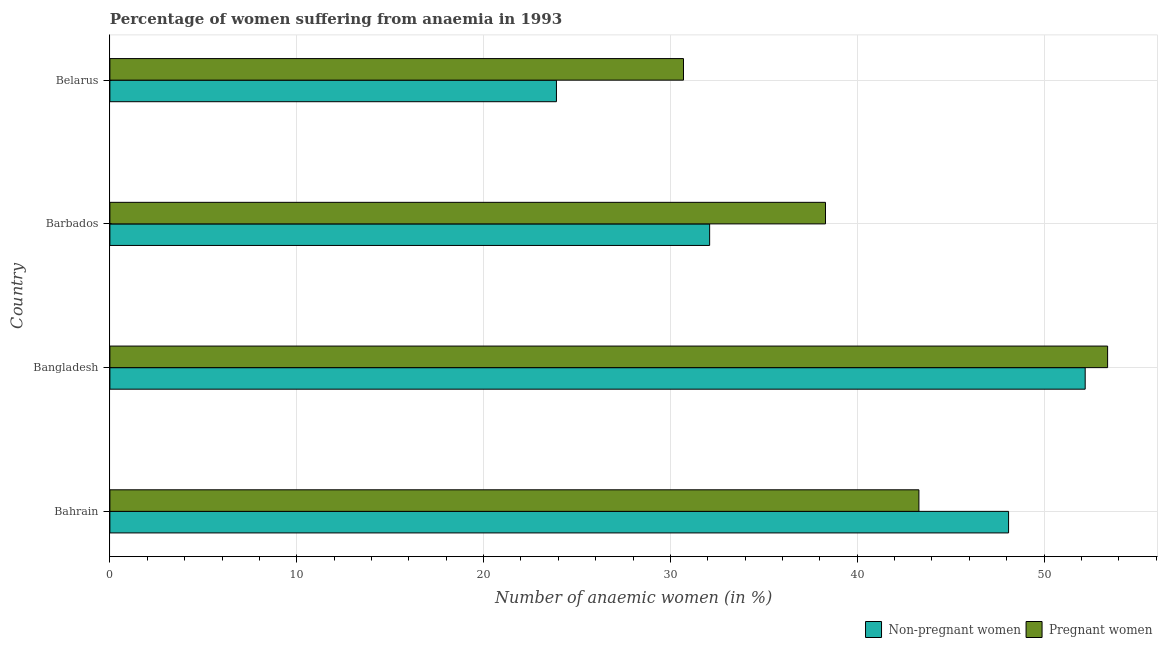Are the number of bars per tick equal to the number of legend labels?
Ensure brevity in your answer.  Yes. How many bars are there on the 1st tick from the bottom?
Offer a terse response. 2. What is the label of the 1st group of bars from the top?
Keep it short and to the point. Belarus. In how many cases, is the number of bars for a given country not equal to the number of legend labels?
Your response must be concise. 0. What is the percentage of pregnant anaemic women in Bangladesh?
Make the answer very short. 53.4. Across all countries, what is the maximum percentage of non-pregnant anaemic women?
Provide a succinct answer. 52.2. Across all countries, what is the minimum percentage of non-pregnant anaemic women?
Offer a terse response. 23.9. In which country was the percentage of pregnant anaemic women minimum?
Offer a terse response. Belarus. What is the total percentage of non-pregnant anaemic women in the graph?
Make the answer very short. 156.3. What is the difference between the percentage of non-pregnant anaemic women in Bangladesh and that in Barbados?
Ensure brevity in your answer.  20.1. What is the difference between the percentage of non-pregnant anaemic women in Bangladesh and the percentage of pregnant anaemic women in Belarus?
Ensure brevity in your answer.  21.5. What is the average percentage of pregnant anaemic women per country?
Offer a terse response. 41.42. In how many countries, is the percentage of non-pregnant anaemic women greater than 42 %?
Offer a terse response. 2. What is the ratio of the percentage of pregnant anaemic women in Bahrain to that in Barbados?
Your answer should be compact. 1.13. What is the difference between the highest and the lowest percentage of pregnant anaemic women?
Offer a very short reply. 22.7. Is the sum of the percentage of non-pregnant anaemic women in Bangladesh and Barbados greater than the maximum percentage of pregnant anaemic women across all countries?
Make the answer very short. Yes. What does the 1st bar from the top in Bangladesh represents?
Provide a succinct answer. Pregnant women. What does the 1st bar from the bottom in Bangladesh represents?
Provide a succinct answer. Non-pregnant women. How many bars are there?
Keep it short and to the point. 8. Are the values on the major ticks of X-axis written in scientific E-notation?
Your response must be concise. No. Does the graph contain any zero values?
Ensure brevity in your answer.  No. Does the graph contain grids?
Offer a terse response. Yes. Where does the legend appear in the graph?
Provide a short and direct response. Bottom right. How many legend labels are there?
Offer a very short reply. 2. What is the title of the graph?
Keep it short and to the point. Percentage of women suffering from anaemia in 1993. Does "Taxes on profits and capital gains" appear as one of the legend labels in the graph?
Provide a short and direct response. No. What is the label or title of the X-axis?
Provide a short and direct response. Number of anaemic women (in %). What is the Number of anaemic women (in %) in Non-pregnant women in Bahrain?
Offer a very short reply. 48.1. What is the Number of anaemic women (in %) in Pregnant women in Bahrain?
Your answer should be compact. 43.3. What is the Number of anaemic women (in %) of Non-pregnant women in Bangladesh?
Your answer should be very brief. 52.2. What is the Number of anaemic women (in %) in Pregnant women in Bangladesh?
Offer a terse response. 53.4. What is the Number of anaemic women (in %) in Non-pregnant women in Barbados?
Your answer should be compact. 32.1. What is the Number of anaemic women (in %) in Pregnant women in Barbados?
Offer a very short reply. 38.3. What is the Number of anaemic women (in %) in Non-pregnant women in Belarus?
Offer a terse response. 23.9. What is the Number of anaemic women (in %) of Pregnant women in Belarus?
Give a very brief answer. 30.7. Across all countries, what is the maximum Number of anaemic women (in %) in Non-pregnant women?
Offer a terse response. 52.2. Across all countries, what is the maximum Number of anaemic women (in %) of Pregnant women?
Make the answer very short. 53.4. Across all countries, what is the minimum Number of anaemic women (in %) in Non-pregnant women?
Give a very brief answer. 23.9. Across all countries, what is the minimum Number of anaemic women (in %) in Pregnant women?
Keep it short and to the point. 30.7. What is the total Number of anaemic women (in %) in Non-pregnant women in the graph?
Provide a succinct answer. 156.3. What is the total Number of anaemic women (in %) in Pregnant women in the graph?
Offer a terse response. 165.7. What is the difference between the Number of anaemic women (in %) of Pregnant women in Bahrain and that in Bangladesh?
Offer a terse response. -10.1. What is the difference between the Number of anaemic women (in %) of Non-pregnant women in Bahrain and that in Barbados?
Provide a succinct answer. 16. What is the difference between the Number of anaemic women (in %) in Non-pregnant women in Bahrain and that in Belarus?
Provide a succinct answer. 24.2. What is the difference between the Number of anaemic women (in %) in Pregnant women in Bahrain and that in Belarus?
Your response must be concise. 12.6. What is the difference between the Number of anaemic women (in %) in Non-pregnant women in Bangladesh and that in Barbados?
Offer a terse response. 20.1. What is the difference between the Number of anaemic women (in %) of Non-pregnant women in Bangladesh and that in Belarus?
Your answer should be very brief. 28.3. What is the difference between the Number of anaemic women (in %) in Pregnant women in Bangladesh and that in Belarus?
Make the answer very short. 22.7. What is the difference between the Number of anaemic women (in %) in Pregnant women in Barbados and that in Belarus?
Ensure brevity in your answer.  7.6. What is the difference between the Number of anaemic women (in %) of Non-pregnant women in Bahrain and the Number of anaemic women (in %) of Pregnant women in Barbados?
Keep it short and to the point. 9.8. What is the difference between the Number of anaemic women (in %) in Non-pregnant women in Bahrain and the Number of anaemic women (in %) in Pregnant women in Belarus?
Provide a succinct answer. 17.4. What is the difference between the Number of anaemic women (in %) of Non-pregnant women in Barbados and the Number of anaemic women (in %) of Pregnant women in Belarus?
Provide a short and direct response. 1.4. What is the average Number of anaemic women (in %) in Non-pregnant women per country?
Ensure brevity in your answer.  39.08. What is the average Number of anaemic women (in %) in Pregnant women per country?
Offer a terse response. 41.42. What is the difference between the Number of anaemic women (in %) of Non-pregnant women and Number of anaemic women (in %) of Pregnant women in Bahrain?
Give a very brief answer. 4.8. What is the difference between the Number of anaemic women (in %) in Non-pregnant women and Number of anaemic women (in %) in Pregnant women in Bangladesh?
Ensure brevity in your answer.  -1.2. What is the ratio of the Number of anaemic women (in %) of Non-pregnant women in Bahrain to that in Bangladesh?
Provide a short and direct response. 0.92. What is the ratio of the Number of anaemic women (in %) in Pregnant women in Bahrain to that in Bangladesh?
Provide a succinct answer. 0.81. What is the ratio of the Number of anaemic women (in %) in Non-pregnant women in Bahrain to that in Barbados?
Your answer should be compact. 1.5. What is the ratio of the Number of anaemic women (in %) of Pregnant women in Bahrain to that in Barbados?
Your response must be concise. 1.13. What is the ratio of the Number of anaemic women (in %) in Non-pregnant women in Bahrain to that in Belarus?
Ensure brevity in your answer.  2.01. What is the ratio of the Number of anaemic women (in %) in Pregnant women in Bahrain to that in Belarus?
Give a very brief answer. 1.41. What is the ratio of the Number of anaemic women (in %) in Non-pregnant women in Bangladesh to that in Barbados?
Ensure brevity in your answer.  1.63. What is the ratio of the Number of anaemic women (in %) of Pregnant women in Bangladesh to that in Barbados?
Provide a succinct answer. 1.39. What is the ratio of the Number of anaemic women (in %) in Non-pregnant women in Bangladesh to that in Belarus?
Provide a short and direct response. 2.18. What is the ratio of the Number of anaemic women (in %) in Pregnant women in Bangladesh to that in Belarus?
Provide a short and direct response. 1.74. What is the ratio of the Number of anaemic women (in %) in Non-pregnant women in Barbados to that in Belarus?
Your response must be concise. 1.34. What is the ratio of the Number of anaemic women (in %) of Pregnant women in Barbados to that in Belarus?
Provide a succinct answer. 1.25. What is the difference between the highest and the second highest Number of anaemic women (in %) of Non-pregnant women?
Your response must be concise. 4.1. What is the difference between the highest and the lowest Number of anaemic women (in %) of Non-pregnant women?
Provide a short and direct response. 28.3. What is the difference between the highest and the lowest Number of anaemic women (in %) in Pregnant women?
Provide a short and direct response. 22.7. 